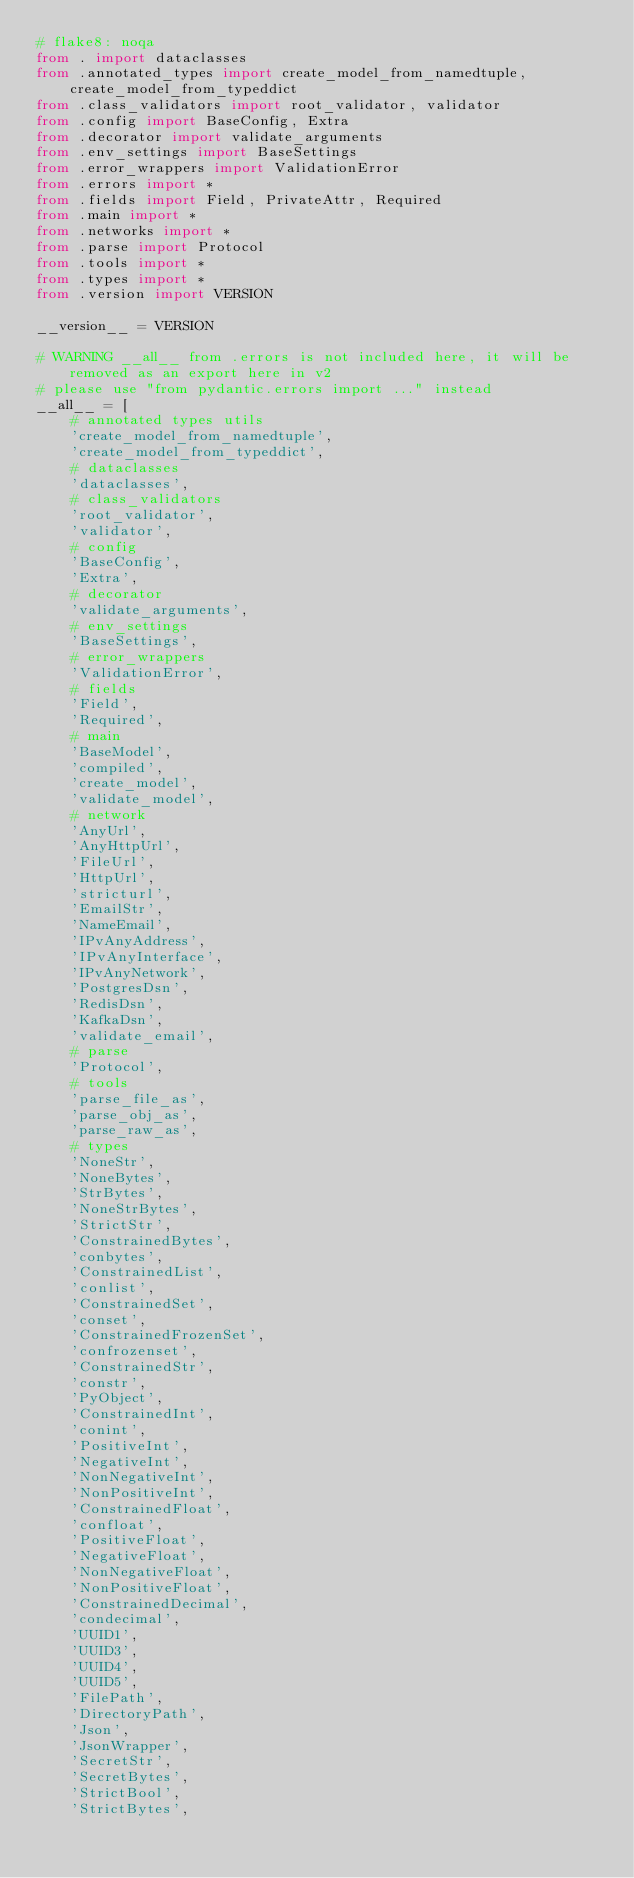<code> <loc_0><loc_0><loc_500><loc_500><_Python_># flake8: noqa
from . import dataclasses
from .annotated_types import create_model_from_namedtuple, create_model_from_typeddict
from .class_validators import root_validator, validator
from .config import BaseConfig, Extra
from .decorator import validate_arguments
from .env_settings import BaseSettings
from .error_wrappers import ValidationError
from .errors import *
from .fields import Field, PrivateAttr, Required
from .main import *
from .networks import *
from .parse import Protocol
from .tools import *
from .types import *
from .version import VERSION

__version__ = VERSION

# WARNING __all__ from .errors is not included here, it will be removed as an export here in v2
# please use "from pydantic.errors import ..." instead
__all__ = [
    # annotated types utils
    'create_model_from_namedtuple',
    'create_model_from_typeddict',
    # dataclasses
    'dataclasses',
    # class_validators
    'root_validator',
    'validator',
    # config
    'BaseConfig',
    'Extra',
    # decorator
    'validate_arguments',
    # env_settings
    'BaseSettings',
    # error_wrappers
    'ValidationError',
    # fields
    'Field',
    'Required',
    # main
    'BaseModel',
    'compiled',
    'create_model',
    'validate_model',
    # network
    'AnyUrl',
    'AnyHttpUrl',
    'FileUrl',
    'HttpUrl',
    'stricturl',
    'EmailStr',
    'NameEmail',
    'IPvAnyAddress',
    'IPvAnyInterface',
    'IPvAnyNetwork',
    'PostgresDsn',
    'RedisDsn',
    'KafkaDsn',
    'validate_email',
    # parse
    'Protocol',
    # tools
    'parse_file_as',
    'parse_obj_as',
    'parse_raw_as',
    # types
    'NoneStr',
    'NoneBytes',
    'StrBytes',
    'NoneStrBytes',
    'StrictStr',
    'ConstrainedBytes',
    'conbytes',
    'ConstrainedList',
    'conlist',
    'ConstrainedSet',
    'conset',
    'ConstrainedFrozenSet',
    'confrozenset',
    'ConstrainedStr',
    'constr',
    'PyObject',
    'ConstrainedInt',
    'conint',
    'PositiveInt',
    'NegativeInt',
    'NonNegativeInt',
    'NonPositiveInt',
    'ConstrainedFloat',
    'confloat',
    'PositiveFloat',
    'NegativeFloat',
    'NonNegativeFloat',
    'NonPositiveFloat',
    'ConstrainedDecimal',
    'condecimal',
    'UUID1',
    'UUID3',
    'UUID4',
    'UUID5',
    'FilePath',
    'DirectoryPath',
    'Json',
    'JsonWrapper',
    'SecretStr',
    'SecretBytes',
    'StrictBool',
    'StrictBytes',</code> 